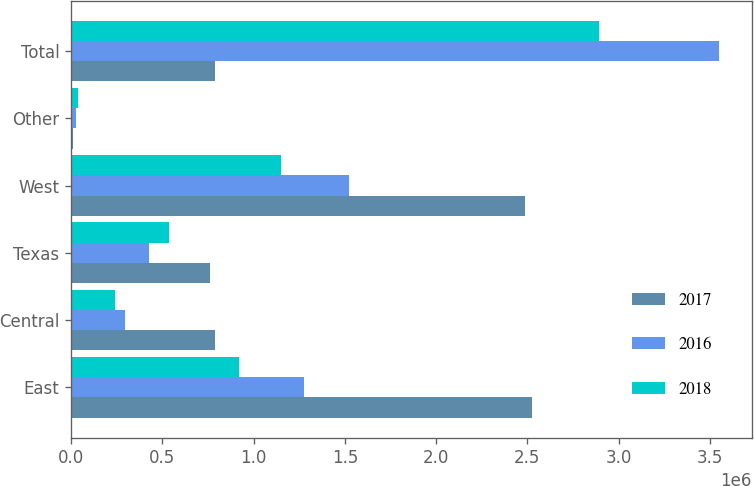<chart> <loc_0><loc_0><loc_500><loc_500><stacked_bar_chart><ecel><fcel>East<fcel>Central<fcel>Texas<fcel>West<fcel>Other<fcel>Total<nl><fcel>2017<fcel>2.52271e+06<fcel>790252<fcel>760721<fcel>2.48745e+06<fcel>8989<fcel>790252<nl><fcel>2016<fcel>1.27385e+06<fcel>295813<fcel>425485<fcel>1.52542e+06<fcel>29797<fcel>3.55037e+06<nl><fcel>2018<fcel>921436<fcel>242950<fcel>537460<fcel>1.15289e+06<fcel>36806<fcel>2.89154e+06<nl></chart> 